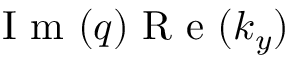<formula> <loc_0><loc_0><loc_500><loc_500>I m ( q ) R e ( k _ { y } )</formula> 